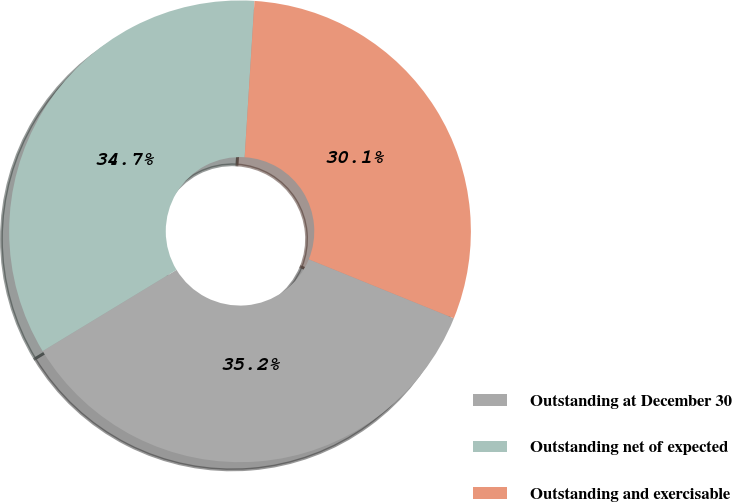Convert chart to OTSL. <chart><loc_0><loc_0><loc_500><loc_500><pie_chart><fcel>Outstanding at December 30<fcel>Outstanding net of expected<fcel>Outstanding and exercisable<nl><fcel>35.17%<fcel>34.68%<fcel>30.15%<nl></chart> 